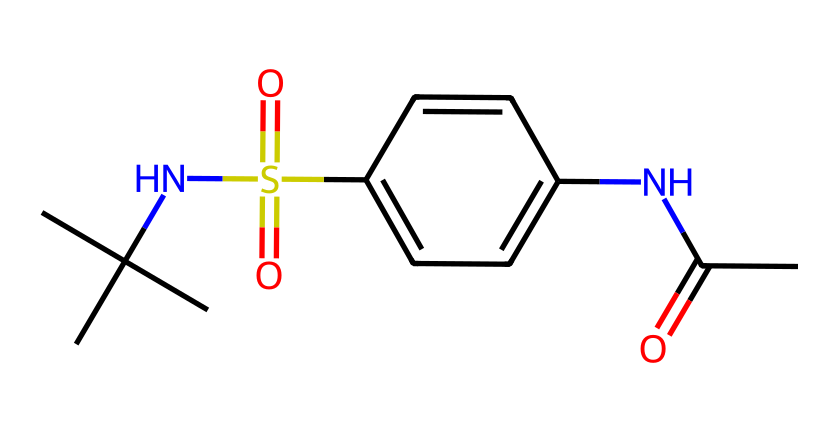What is the primary functional group in this compound? The structure contains an amide functional group, indicated by the -C(=O)-N structure. This is characterized by a carbonyl (C=O) directly bonded to a nitrogen atom.
Answer: amide How many carbon atoms are present in the chemical structure? By examining the SMILES notation, we can count the number of 'C' indicators; there are a total of 10 carbon atoms in the structure.
Answer: 10 What type of bonding is present between the nitrogen and carbon in the amide group? In the amide functional group, the nitrogen atom is connected to the carbon atom via a single bond and also involves a double bond with oxygen in the carbonyl, indicating both single and double bonding is present.
Answer: single and double What does the presence of the sulfonyl group (S(=O)(=O)) suggest about the compound's properties? The sulfonyl group could indicate that the compound has increased solubility in water due to the polar nature of the sulfur-oxygen bonds, enhancing its overall aqueous properties.
Answer: increased solubility How many nitrogen atoms are found in this molecule? The SMILES representation contains two instances of 'N', indicating that there are two nitrogen atoms present in the structure.
Answer: 2 What potential effect does this molecule have on sweetness perception? The presence of specific moieties like the sulfonamide could suggest that this compound mimics the sugar's sweetness mechanism, which is crucial for its use as a sweetener, even though it is not sugar itself.
Answer: sweetness perception Does the presence of the isopropyl group suggest anything about this liquid's volatility? The isopropyl group increases the branching of the compound, which typically lowers the volatility of organic compounds due to decreased surface area for evaporation and increased intermolecular interactions.
Answer: lower volatility 